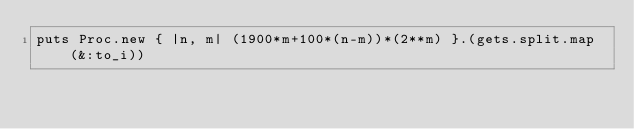Convert code to text. <code><loc_0><loc_0><loc_500><loc_500><_Ruby_>puts Proc.new { |n, m| (1900*m+100*(n-m))*(2**m) }.(gets.split.map(&:to_i))
</code> 